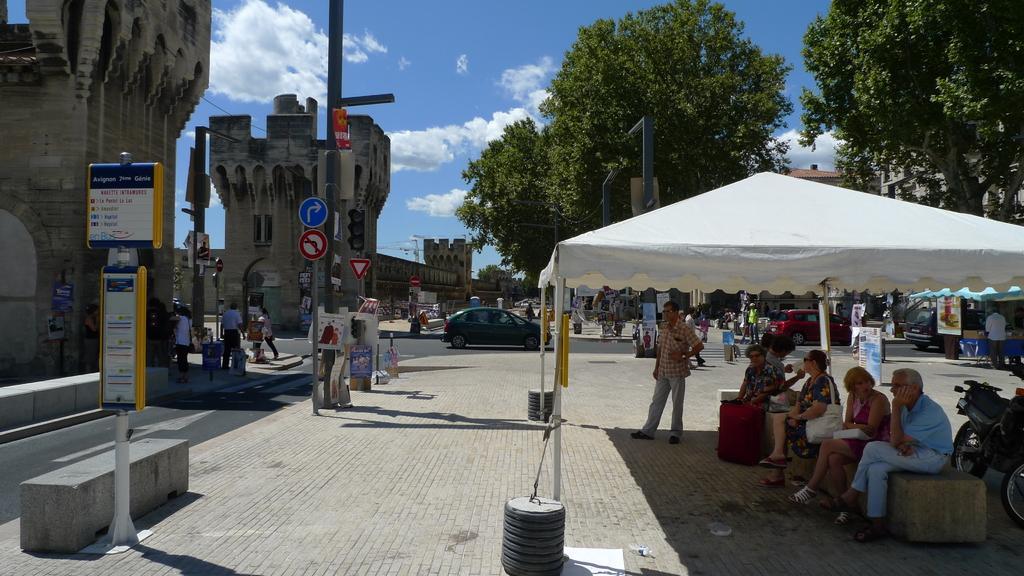Please provide a concise description of this image. In this image on the right side there is a tent and under the tent there are some people sitting on a wall like thing, and there is a bike and on the left side of the image there are some towers, poles, sign boards, walkway and some people are standing and some of them are walking and objects. At the bottom there is a walkway and objects in the center, and there are some papers. In the background there are some trees, vehicles and some people buildings, and at the top there is sky. 